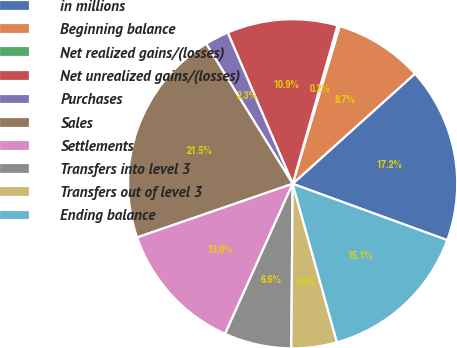<chart> <loc_0><loc_0><loc_500><loc_500><pie_chart><fcel>in millions<fcel>Beginning balance<fcel>Net realized gains/(losses)<fcel>Net unrealized gains/(losses)<fcel>Purchases<fcel>Sales<fcel>Settlements<fcel>Transfers into level 3<fcel>Transfers out of level 3<fcel>Ending balance<nl><fcel>17.23%<fcel>8.72%<fcel>0.22%<fcel>10.85%<fcel>2.35%<fcel>21.48%<fcel>12.98%<fcel>6.6%<fcel>4.47%<fcel>15.1%<nl></chart> 